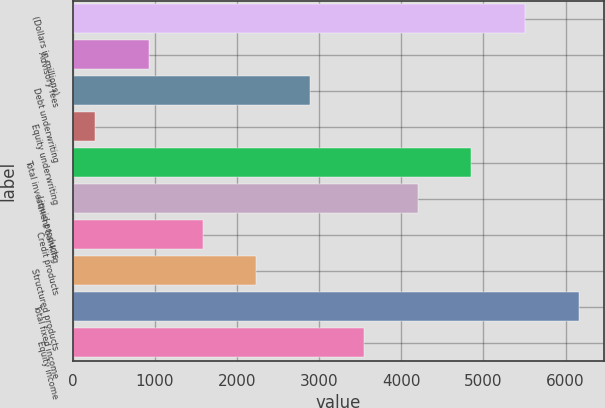<chart> <loc_0><loc_0><loc_500><loc_500><bar_chart><fcel>(Dollars in millions)<fcel>Advisory fees<fcel>Debt underwriting<fcel>Equity underwriting<fcel>Total investment banking<fcel>Liquid products<fcel>Credit products<fcel>Structured products<fcel>Total fixed income<fcel>Equity income<nl><fcel>5509<fcel>927.5<fcel>2891<fcel>273<fcel>4854.5<fcel>4200<fcel>1582<fcel>2236.5<fcel>6163.5<fcel>3545.5<nl></chart> 